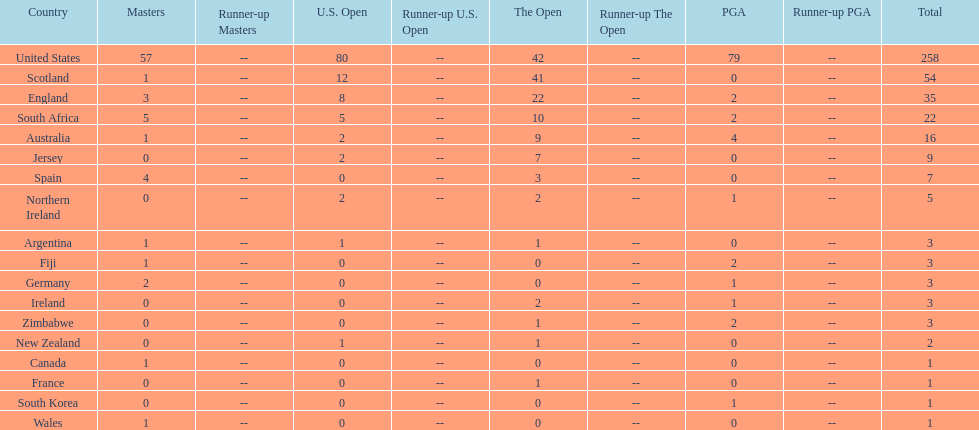Combined, how many winning golfers does england and wales have in the masters? 4. 